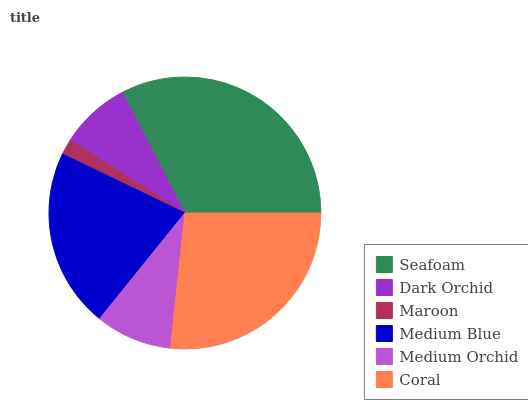Is Maroon the minimum?
Answer yes or no. Yes. Is Seafoam the maximum?
Answer yes or no. Yes. Is Dark Orchid the minimum?
Answer yes or no. No. Is Dark Orchid the maximum?
Answer yes or no. No. Is Seafoam greater than Dark Orchid?
Answer yes or no. Yes. Is Dark Orchid less than Seafoam?
Answer yes or no. Yes. Is Dark Orchid greater than Seafoam?
Answer yes or no. No. Is Seafoam less than Dark Orchid?
Answer yes or no. No. Is Medium Blue the high median?
Answer yes or no. Yes. Is Medium Orchid the low median?
Answer yes or no. Yes. Is Maroon the high median?
Answer yes or no. No. Is Dark Orchid the low median?
Answer yes or no. No. 